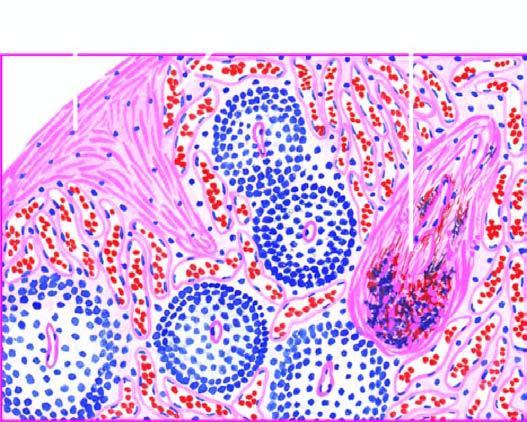re the sinuses dilated and congested?
Answer the question using a single word or phrase. Yes 